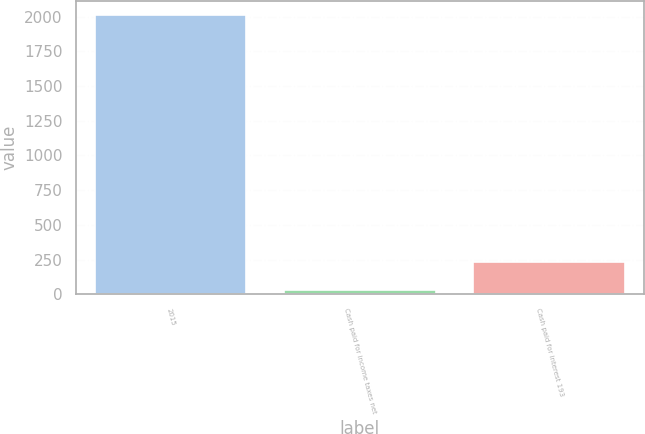<chart> <loc_0><loc_0><loc_500><loc_500><bar_chart><fcel>2015<fcel>Cash paid for income taxes net<fcel>Cash paid for interest 193<nl><fcel>2014<fcel>34<fcel>232<nl></chart> 